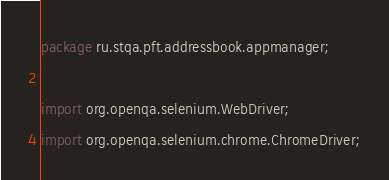<code> <loc_0><loc_0><loc_500><loc_500><_Java_>package ru.stqa.pft.addressbook.appmanager;

import org.openqa.selenium.WebDriver;
import org.openqa.selenium.chrome.ChromeDriver;</code> 